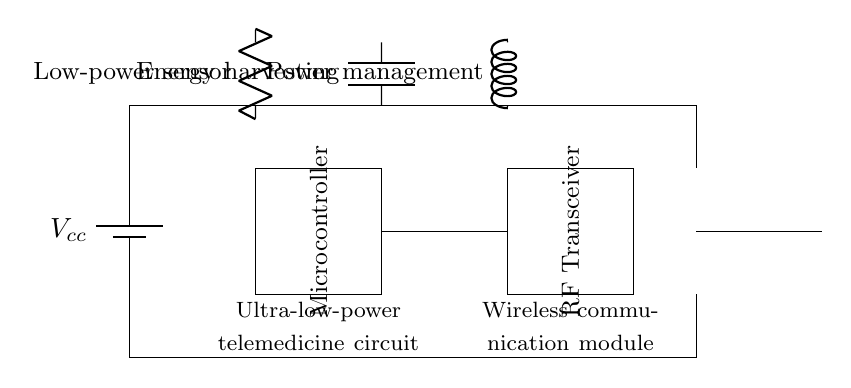What is the function of the microcontroller? The microcontroller serves as the central processing unit of the circuit, managing signals and controlling other components for telemedicine applications.
Answer: Central processing unit What type of sensor is indicated in the circuit? The circuit diagram features a low-power sensor designed to operate efficiently within the ultra-low-power framework.
Answer: Low-power sensor How is power managed in the circuit? Power management is implemented through a dedicated power management component, which regulates the power supplied to ensure efficient operation of all low-power devices.
Answer: Power management component What is the purpose of the RF transceiver? The RF transceiver facilitates wireless communication, allowing devices to send and receive data over radio frequencies, essential in telemedicine setups.
Answer: Wireless communication What is the role of energy harvesting in this circuit? Energy harvesting captures and converts ambient energy sources into electrical energy, ensuring the circuit operates efficiently with minimal battery consumption.
Answer: Converts ambient energy What connections are made between the microcontroller and RF transceiver? The microcontroller is connected to the RF transceiver directly, enabling it to send commands and receive data, which is crucial for the telemedicine application.
Answer: Direct connection What type of circuit is this design categorized as? This design is categorized as an ultra-low-power circuit, optimized for low energy consumption while supporting wireless communication in telemedicine applications.
Answer: Ultra-low-power circuit 